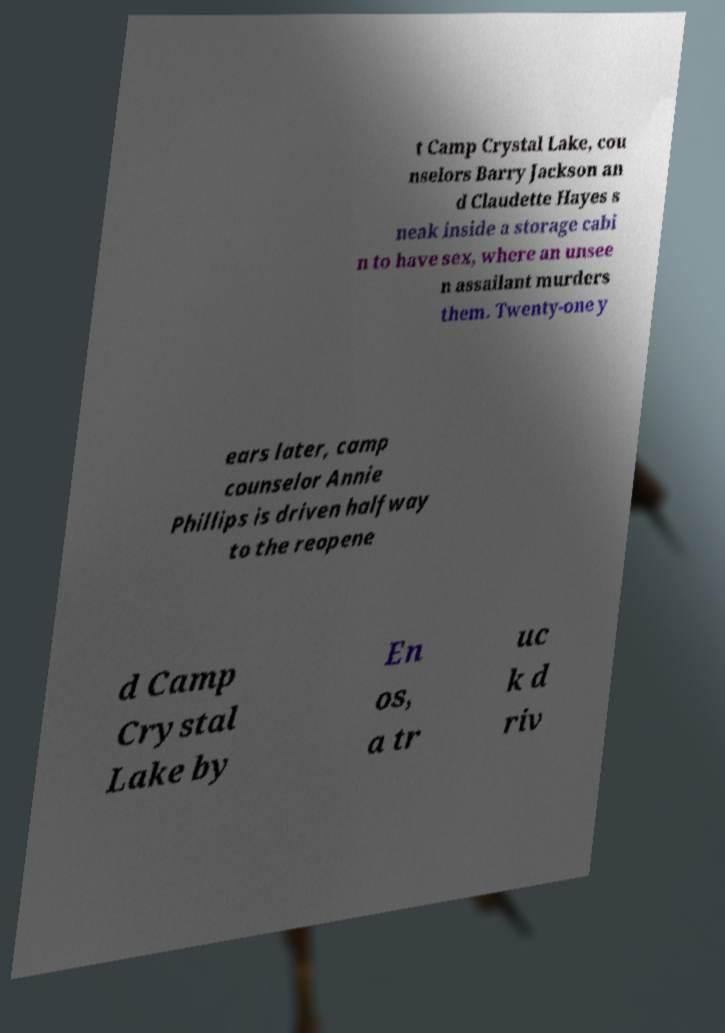Can you accurately transcribe the text from the provided image for me? t Camp Crystal Lake, cou nselors Barry Jackson an d Claudette Hayes s neak inside a storage cabi n to have sex, where an unsee n assailant murders them. Twenty-one y ears later, camp counselor Annie Phillips is driven halfway to the reopene d Camp Crystal Lake by En os, a tr uc k d riv 